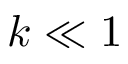<formula> <loc_0><loc_0><loc_500><loc_500>k \ll 1</formula> 